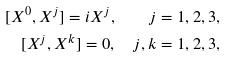<formula> <loc_0><loc_0><loc_500><loc_500>[ X ^ { 0 } , X ^ { j } ] = i X ^ { j } , \quad j = 1 , 2 , 3 , \\ [ X ^ { j } , X ^ { k } ] = 0 , \quad j , k = 1 , 2 , 3 ,</formula> 